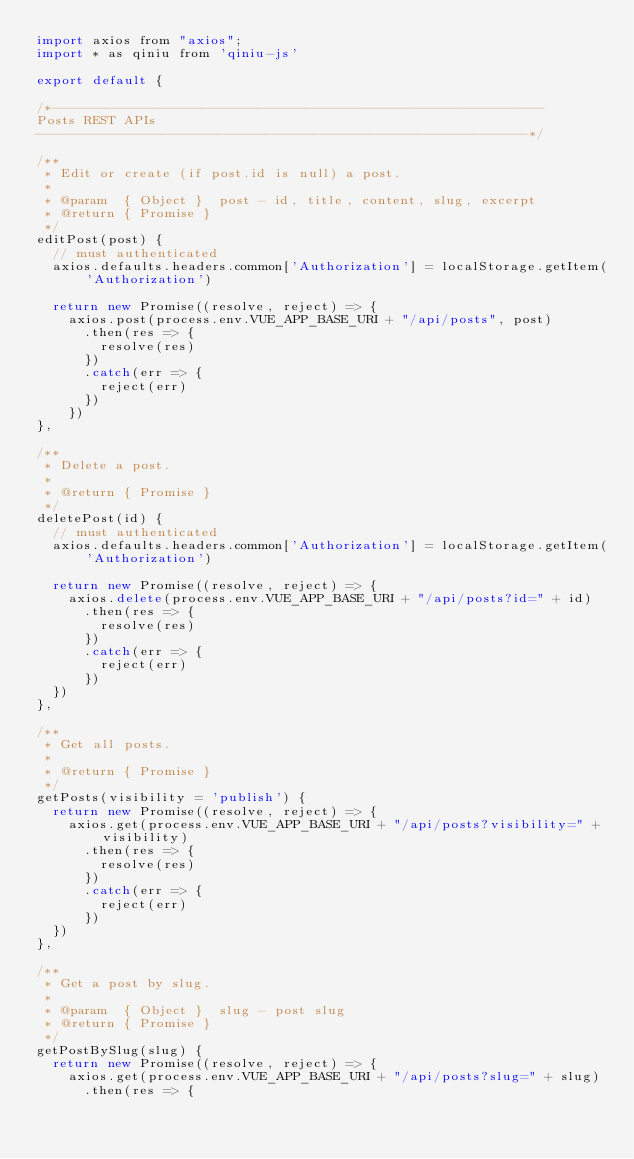Convert code to text. <code><loc_0><loc_0><loc_500><loc_500><_JavaScript_>import axios from "axios";
import * as qiniu from 'qiniu-js'

export default {

/*--------------------------------------------------------------
Posts REST APIs
--------------------------------------------------------------*/

/**
 * Edit or create (if post.id is null) a post.
 *
 * @param  { Object }  post - id, title, content, slug, excerpt
 * @return { Promise }
 */
editPost(post) {
  // must authenticated
  axios.defaults.headers.common['Authorization'] = localStorage.getItem('Authorization')

  return new Promise((resolve, reject) => {
    axios.post(process.env.VUE_APP_BASE_URI + "/api/posts", post)
      .then(res => {
        resolve(res)
      })
      .catch(err => {
        reject(err)
      })
    })
},

/**
 * Delete a post.
 *
 * @return { Promise }
 */
deletePost(id) {
  // must authenticated
  axios.defaults.headers.common['Authorization'] = localStorage.getItem('Authorization')

  return new Promise((resolve, reject) => {
    axios.delete(process.env.VUE_APP_BASE_URI + "/api/posts?id=" + id)
      .then(res => {
        resolve(res)
      })
      .catch(err => {
        reject(err)
      })
  })
},

/**
 * Get all posts.
 *
 * @return { Promise }
 */
getPosts(visibility = 'publish') {
  return new Promise((resolve, reject) => {
    axios.get(process.env.VUE_APP_BASE_URI + "/api/posts?visibility=" + visibility)
      .then(res => {
        resolve(res)
      })
      .catch(err => {
        reject(err)
      })
  })
},

/**
 * Get a post by slug.
 *
 * @param  { Object }  slug - post slug
 * @return { Promise }
 */
getPostBySlug(slug) {
  return new Promise((resolve, reject) => {
    axios.get(process.env.VUE_APP_BASE_URI + "/api/posts?slug=" + slug)
      .then(res => {</code> 